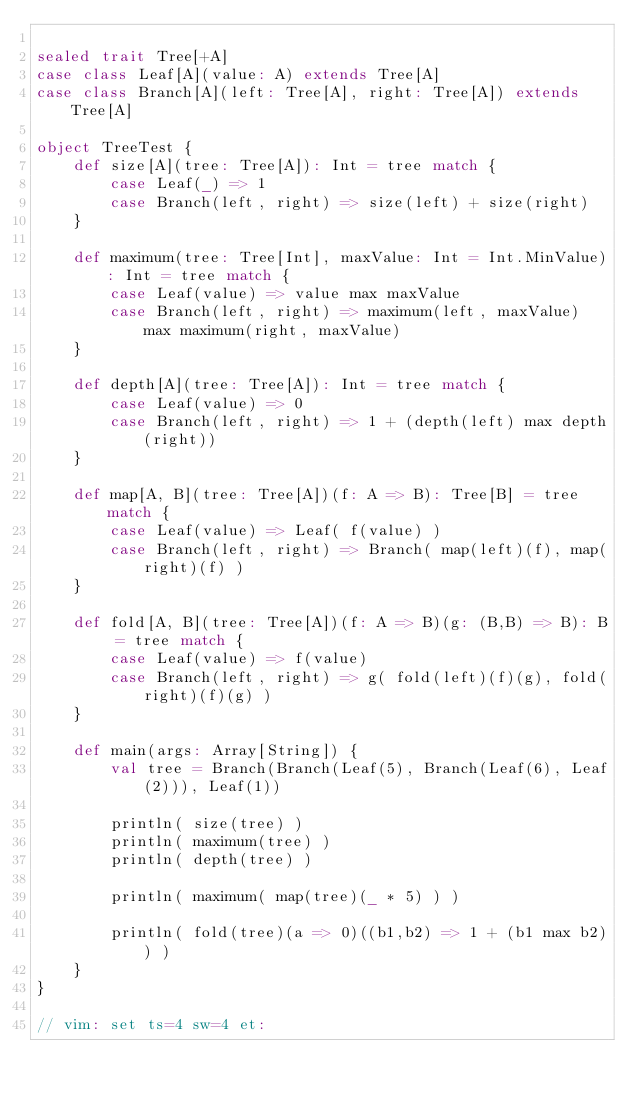Convert code to text. <code><loc_0><loc_0><loc_500><loc_500><_Scala_>
sealed trait Tree[+A]
case class Leaf[A](value: A) extends Tree[A]
case class Branch[A](left: Tree[A], right: Tree[A]) extends Tree[A]

object TreeTest {
    def size[A](tree: Tree[A]): Int = tree match {
        case Leaf(_) => 1
        case Branch(left, right) => size(left) + size(right)
    }

    def maximum(tree: Tree[Int], maxValue: Int = Int.MinValue): Int = tree match {
        case Leaf(value) => value max maxValue
        case Branch(left, right) => maximum(left, maxValue) max maximum(right, maxValue)
    }

    def depth[A](tree: Tree[A]): Int = tree match {
        case Leaf(value) => 0
        case Branch(left, right) => 1 + (depth(left) max depth(right))
    }

    def map[A, B](tree: Tree[A])(f: A => B): Tree[B] = tree match {
        case Leaf(value) => Leaf( f(value) )
        case Branch(left, right) => Branch( map(left)(f), map(right)(f) )
    }

    def fold[A, B](tree: Tree[A])(f: A => B)(g: (B,B) => B): B = tree match {
        case Leaf(value) => f(value)
        case Branch(left, right) => g( fold(left)(f)(g), fold(right)(f)(g) )
    }

    def main(args: Array[String]) {
        val tree = Branch(Branch(Leaf(5), Branch(Leaf(6), Leaf(2))), Leaf(1))

        println( size(tree) )
        println( maximum(tree) )
        println( depth(tree) )

        println( maximum( map(tree)(_ * 5) ) )

        println( fold(tree)(a => 0)((b1,b2) => 1 + (b1 max b2)) )
    }
}

// vim: set ts=4 sw=4 et:
</code> 